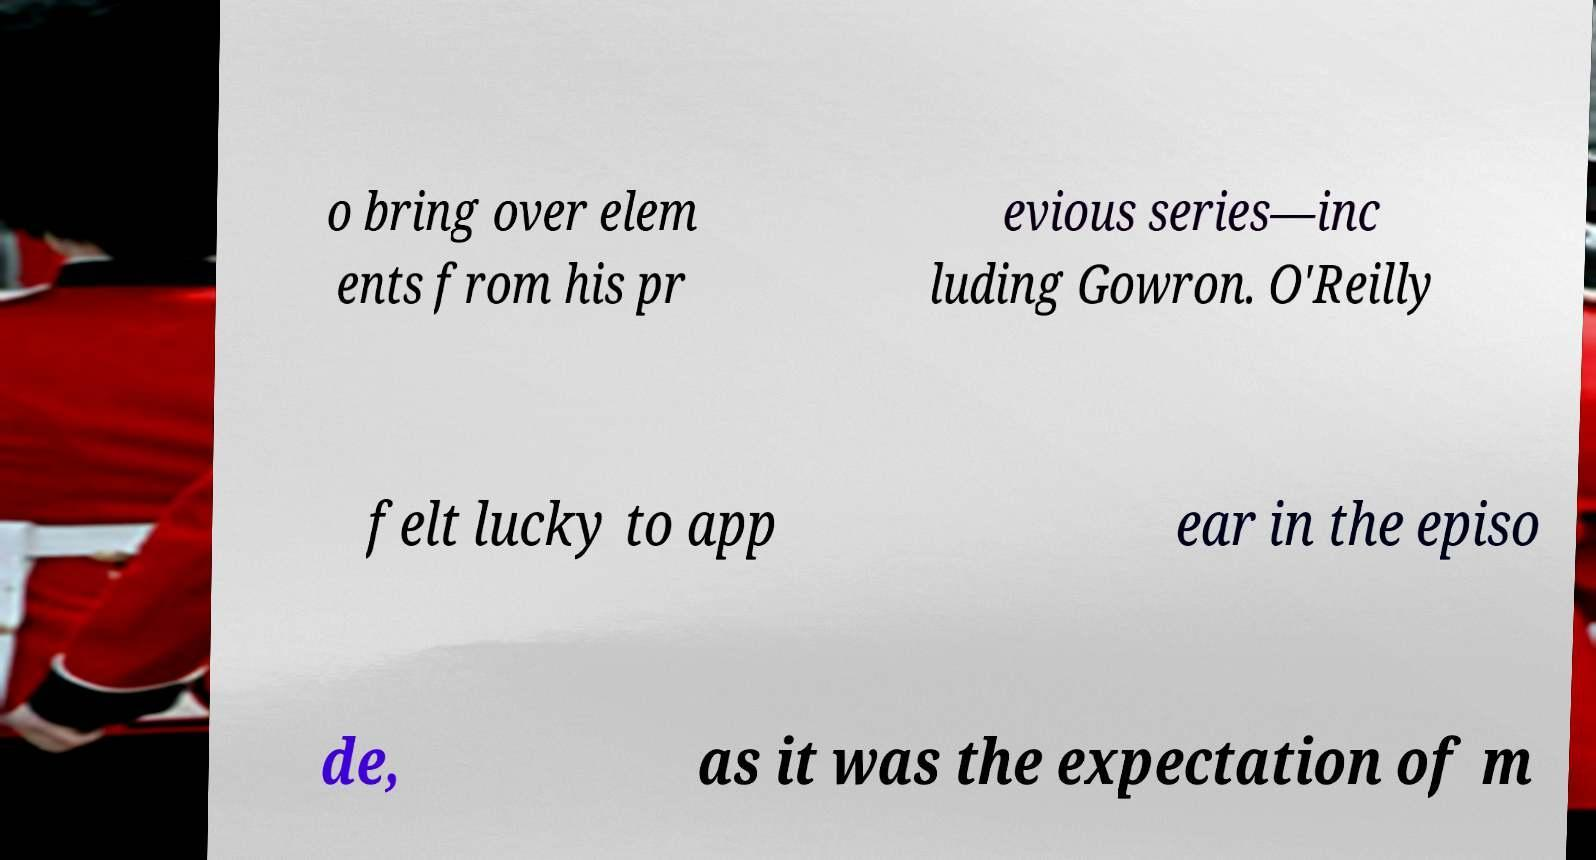Please read and relay the text visible in this image. What does it say? o bring over elem ents from his pr evious series—inc luding Gowron. O'Reilly felt lucky to app ear in the episo de, as it was the expectation of m 